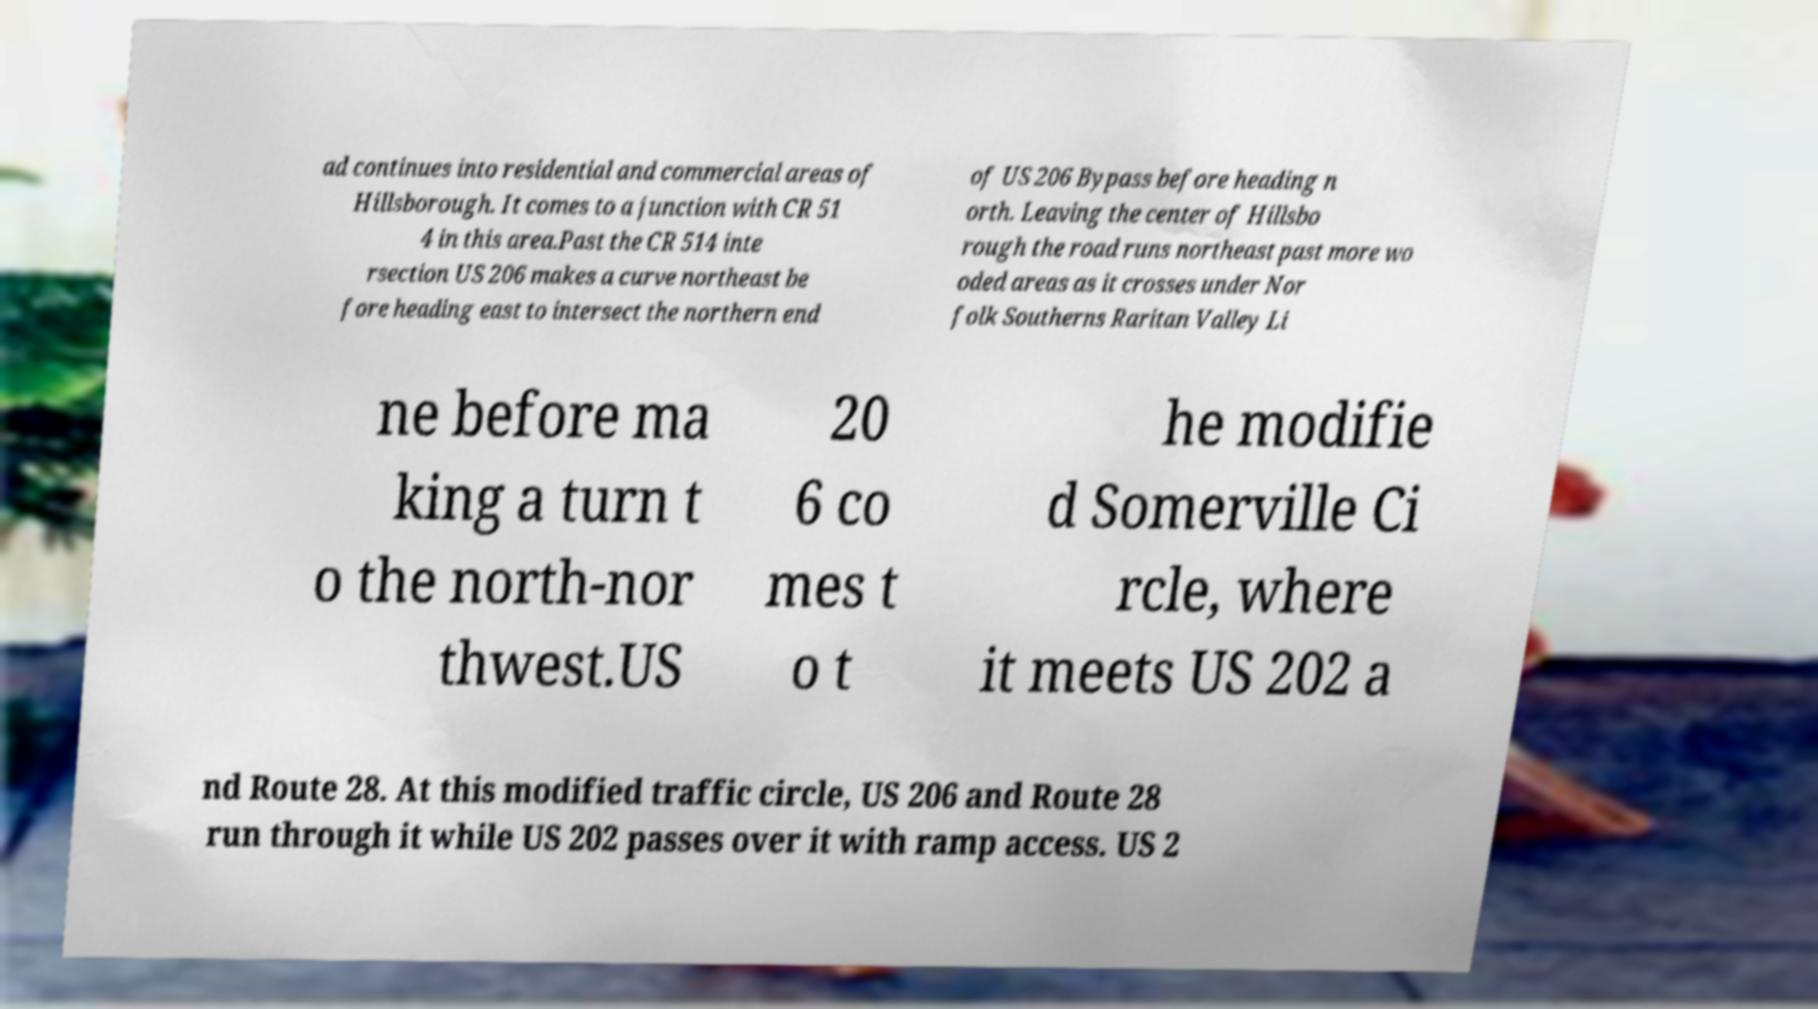Can you accurately transcribe the text from the provided image for me? ad continues into residential and commercial areas of Hillsborough. It comes to a junction with CR 51 4 in this area.Past the CR 514 inte rsection US 206 makes a curve northeast be fore heading east to intersect the northern end of US 206 Bypass before heading n orth. Leaving the center of Hillsbo rough the road runs northeast past more wo oded areas as it crosses under Nor folk Southerns Raritan Valley Li ne before ma king a turn t o the north-nor thwest.US 20 6 co mes t o t he modifie d Somerville Ci rcle, where it meets US 202 a nd Route 28. At this modified traffic circle, US 206 and Route 28 run through it while US 202 passes over it with ramp access. US 2 